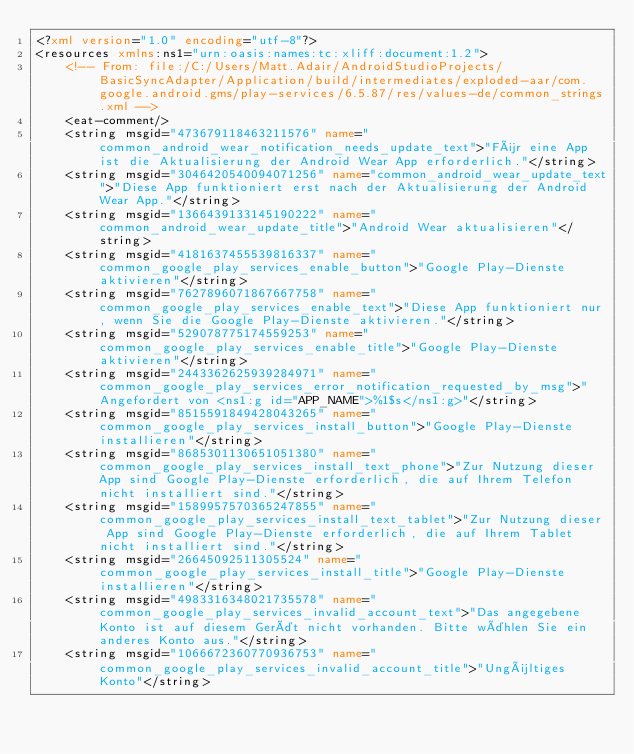<code> <loc_0><loc_0><loc_500><loc_500><_XML_><?xml version="1.0" encoding="utf-8"?>
<resources xmlns:ns1="urn:oasis:names:tc:xliff:document:1.2">
    <!-- From: file:/C:/Users/Matt.Adair/AndroidStudioProjects/BasicSyncAdapter/Application/build/intermediates/exploded-aar/com.google.android.gms/play-services/6.5.87/res/values-de/common_strings.xml -->
    <eat-comment/>
    <string msgid="473679118463211576" name="common_android_wear_notification_needs_update_text">"Für eine App ist die Aktualisierung der Android Wear App erforderlich."</string>
    <string msgid="3046420540094071256" name="common_android_wear_update_text">"Diese App funktioniert erst nach der Aktualisierung der Android Wear App."</string>
    <string msgid="1366439133145190222" name="common_android_wear_update_title">"Android Wear aktualisieren"</string>
    <string msgid="4181637455539816337" name="common_google_play_services_enable_button">"Google Play-Dienste aktivieren"</string>
    <string msgid="7627896071867667758" name="common_google_play_services_enable_text">"Diese App funktioniert nur, wenn Sie die Google Play-Dienste aktivieren."</string>
    <string msgid="529078775174559253" name="common_google_play_services_enable_title">"Google Play-Dienste aktivieren"</string>
    <string msgid="2443362625939284971" name="common_google_play_services_error_notification_requested_by_msg">"Angefordert von <ns1:g id="APP_NAME">%1$s</ns1:g>"</string>
    <string msgid="8515591849428043265" name="common_google_play_services_install_button">"Google Play-Dienste installieren"</string>
    <string msgid="8685301130651051380" name="common_google_play_services_install_text_phone">"Zur Nutzung dieser App sind Google Play-Dienste erforderlich, die auf Ihrem Telefon nicht installiert sind."</string>
    <string msgid="1589957570365247855" name="common_google_play_services_install_text_tablet">"Zur Nutzung dieser App sind Google Play-Dienste erforderlich, die auf Ihrem Tablet nicht installiert sind."</string>
    <string msgid="26645092511305524" name="common_google_play_services_install_title">"Google Play-Dienste installieren"</string>
    <string msgid="4983316348021735578" name="common_google_play_services_invalid_account_text">"Das angegebene Konto ist auf diesem Gerät nicht vorhanden. Bitte wählen Sie ein anderes Konto aus."</string>
    <string msgid="1066672360770936753" name="common_google_play_services_invalid_account_title">"Ungültiges Konto"</string></code> 